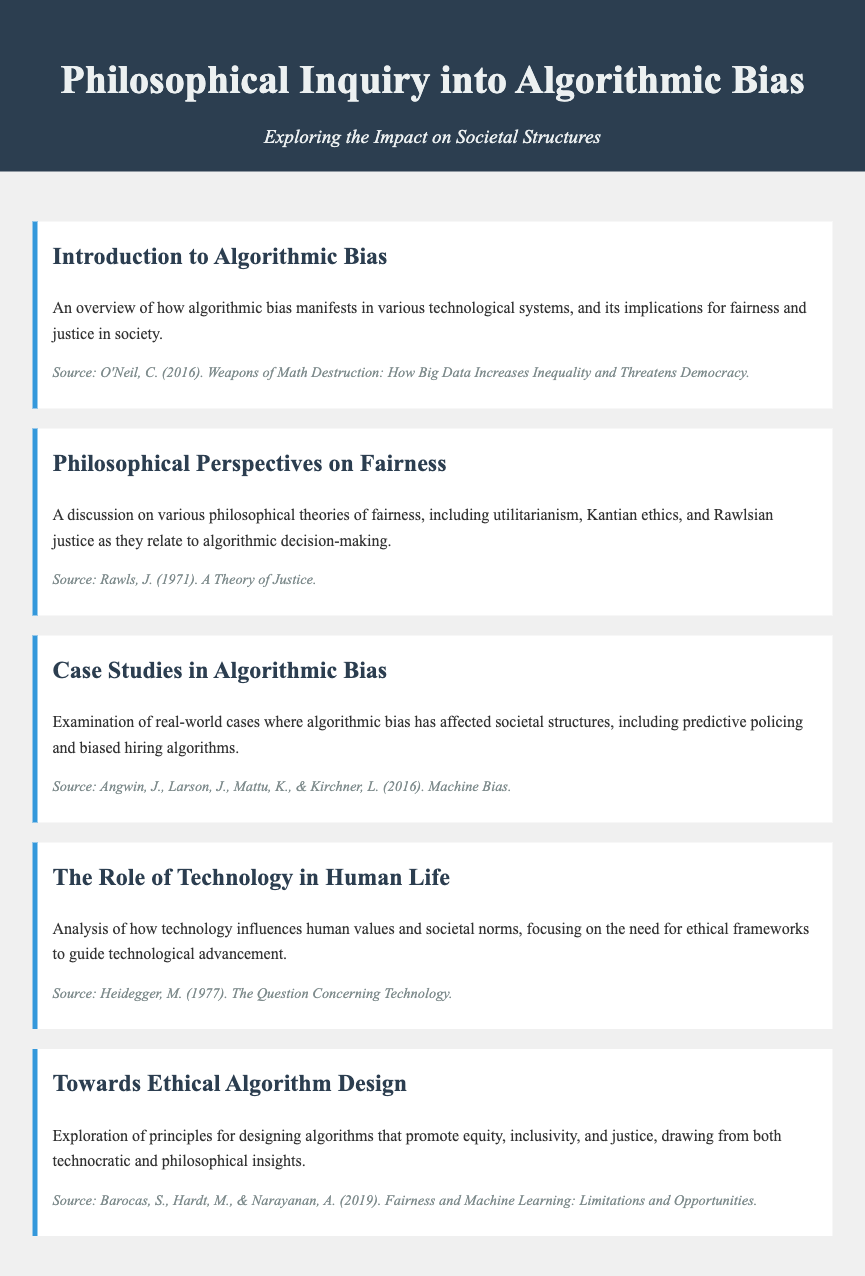what is the title of the document? The title is displayed prominently in the header of the document.
Answer: Philosophical Inquiry into Algorithmic Bias who is the author of "Weapons of Math Destruction"? This is noted in the source of the introduction section of the document.
Answer: Cathy O'Neil what year was "A Theory of Justice" published? The publication year is cited in the source of the philosophical perspectives section.
Answer: 1971 which concepts are analyzed in the section on the role of technology? This section discusses the influence of technology on human values and societal norms.
Answer: Human values and societal norms name one case mentioned in the case studies section. The document lists specific examples of algorithmic bias affecting society.
Answer: Predictive policing what ethical frameworks are suggested in the section on ethical algorithm design? The section outlines principles for promoting equity, inclusivity, and justice.
Answer: Equity, inclusivity, and justice what philosophical theory is discussed in relation to algorithmic decision-making? This theory is mentioned under the philosophical perspectives section.
Answer: Utilitarianism how many menu items does the document contain? The document lists several distinct sections or topics related to algorithmic bias.
Answer: Five 